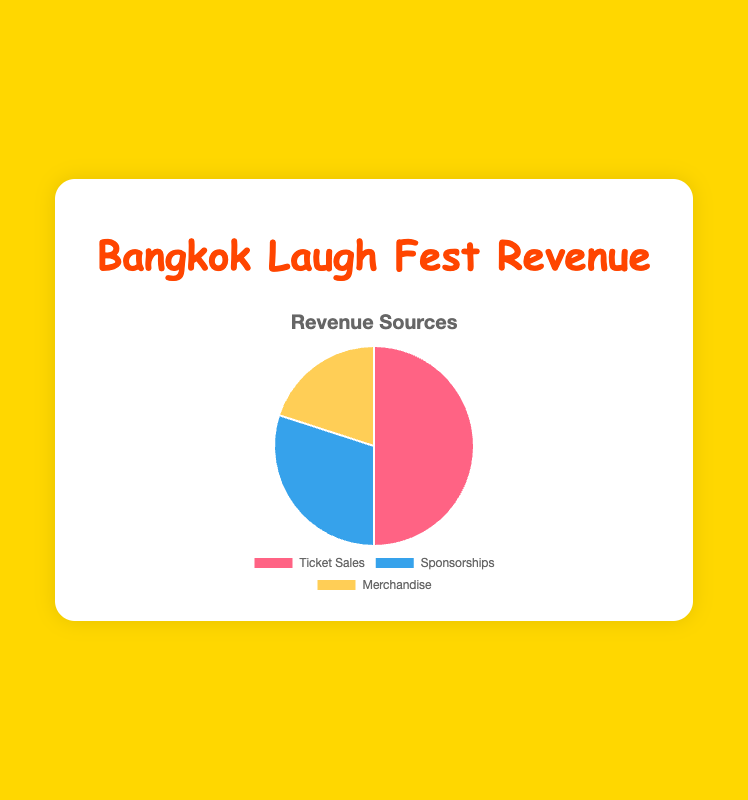What percentage of revenue comes from Ticket Sales in the Bangkok Laugh Fest? Ticket Sales account for 50% of the revenue. Interpreting the pie chart, the 'Ticket Sales' section occupies half of the chart.
Answer: 50% By how many percentage points do Ticket Sales exceed Merchandise Sales in the Bangkok Laugh Fest? Ticket Sales make up 50% of the revenue while Merchandise Sales contribute 20%. Therefore, Ticket Sales exceed Merchandise Sales by 30 percentage points (50% - 20%).
Answer: 30 percentage points Which revenue source has the smallest contribution in the Bangkok Laugh Fest? Observing the pie chart, the smallest section is the 'Merchandise' section, which is 20%.
Answer: Merchandise What is the total percentage of revenue that comes from Sponsorships and Merchandise combined in the Bangkok Laugh Fest? Sponsorships contribute 30% and Merchandise contributes 20%. Adding them together gives 30% + 20% = 50%.
Answer: 50% What is the ratio of revenue from Ticket Sales to Sponsorships in the Bangkok Laugh Fest? Ticket Sales account for 50% of the revenue and Sponsorships account for 30%. The ratio of Ticket Sales to Sponsorships is 50:30, which simplifies to 5:3.
Answer: 5:3 If Merchandise revenue increased by 10 percentage points, what would be its new percentage of the total revenue? Merchandise currently contributes 20%. With an increase of 10 percentage points, it would be 20% + 10% = 30%.
Answer: 30% Which source contributes more to the revenue: Sponsorships or Merchandise in the Bangkok Laugh Fest? Sponsorships contribute 30% and Merchandise contributes 20%. Sponsorships contribute more than Merchandise.
Answer: Sponsorships How much greater is the percentage of revenue from Ticket Sales compared to Sponsorships in the Bangkok Laugh Fest? Ticket Sales contribute 50%, and Sponsorships contribute 30%. The difference is 50% - 30% = 20%.
Answer: 20% If you combined the revenue from Sponsorships and Merchandise, would it exceed the revenue from Ticket Sales in the Bangkok Laugh Fest? Sponsorships and Merchandise together make up 30% + 20% = 50%, which is equal to the revenue from Ticket Sales. Therefore, the combined revenue does not exceed Ticket Sales but is equal.
Answer: No 